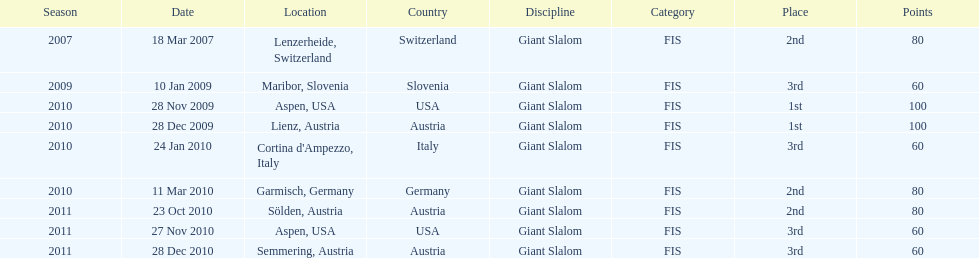The final race finishing place was not 1st but what other place? 3rd. 